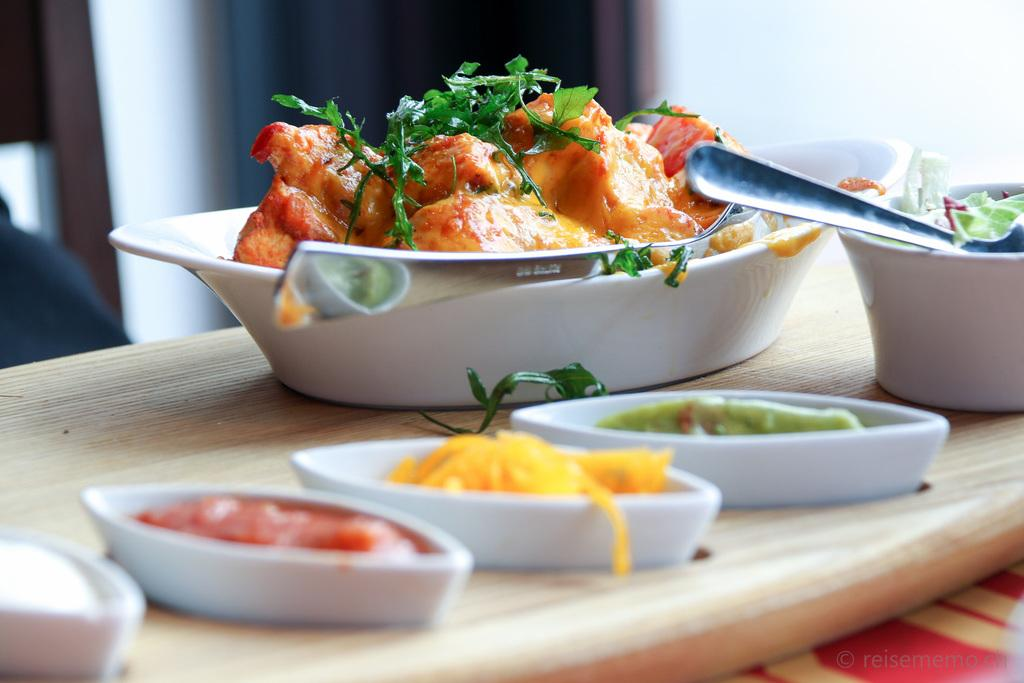What can be seen in the foreground of the picture? There are food items, spoons, and bowls on a wooden platter in the foreground of the picture. What type of utensils are visible in the foreground? There are spoons in the foreground of the picture. How are the bowls arranged in the foreground? The bowls are on a wooden platter in the foreground of the picture. What can be observed about the background of the image? The background of the image is blurred. What color of paint is being used by the food items in the image? There is no paint or painting activity depicted in the image; it features food items, spoons, and bowls on a wooden platter. How do the food items act in the image? The food items are not capable of acting, as they are inanimate objects. 